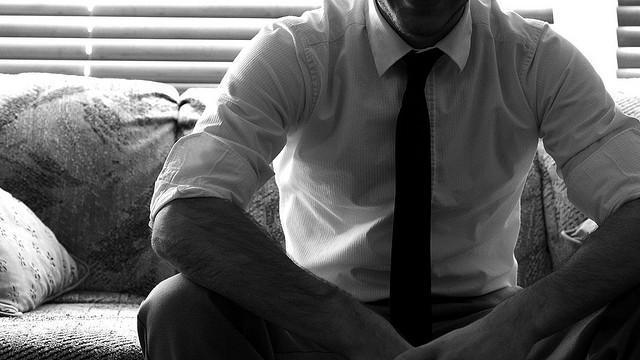How many giraffes are in the picture?
Give a very brief answer. 0. 